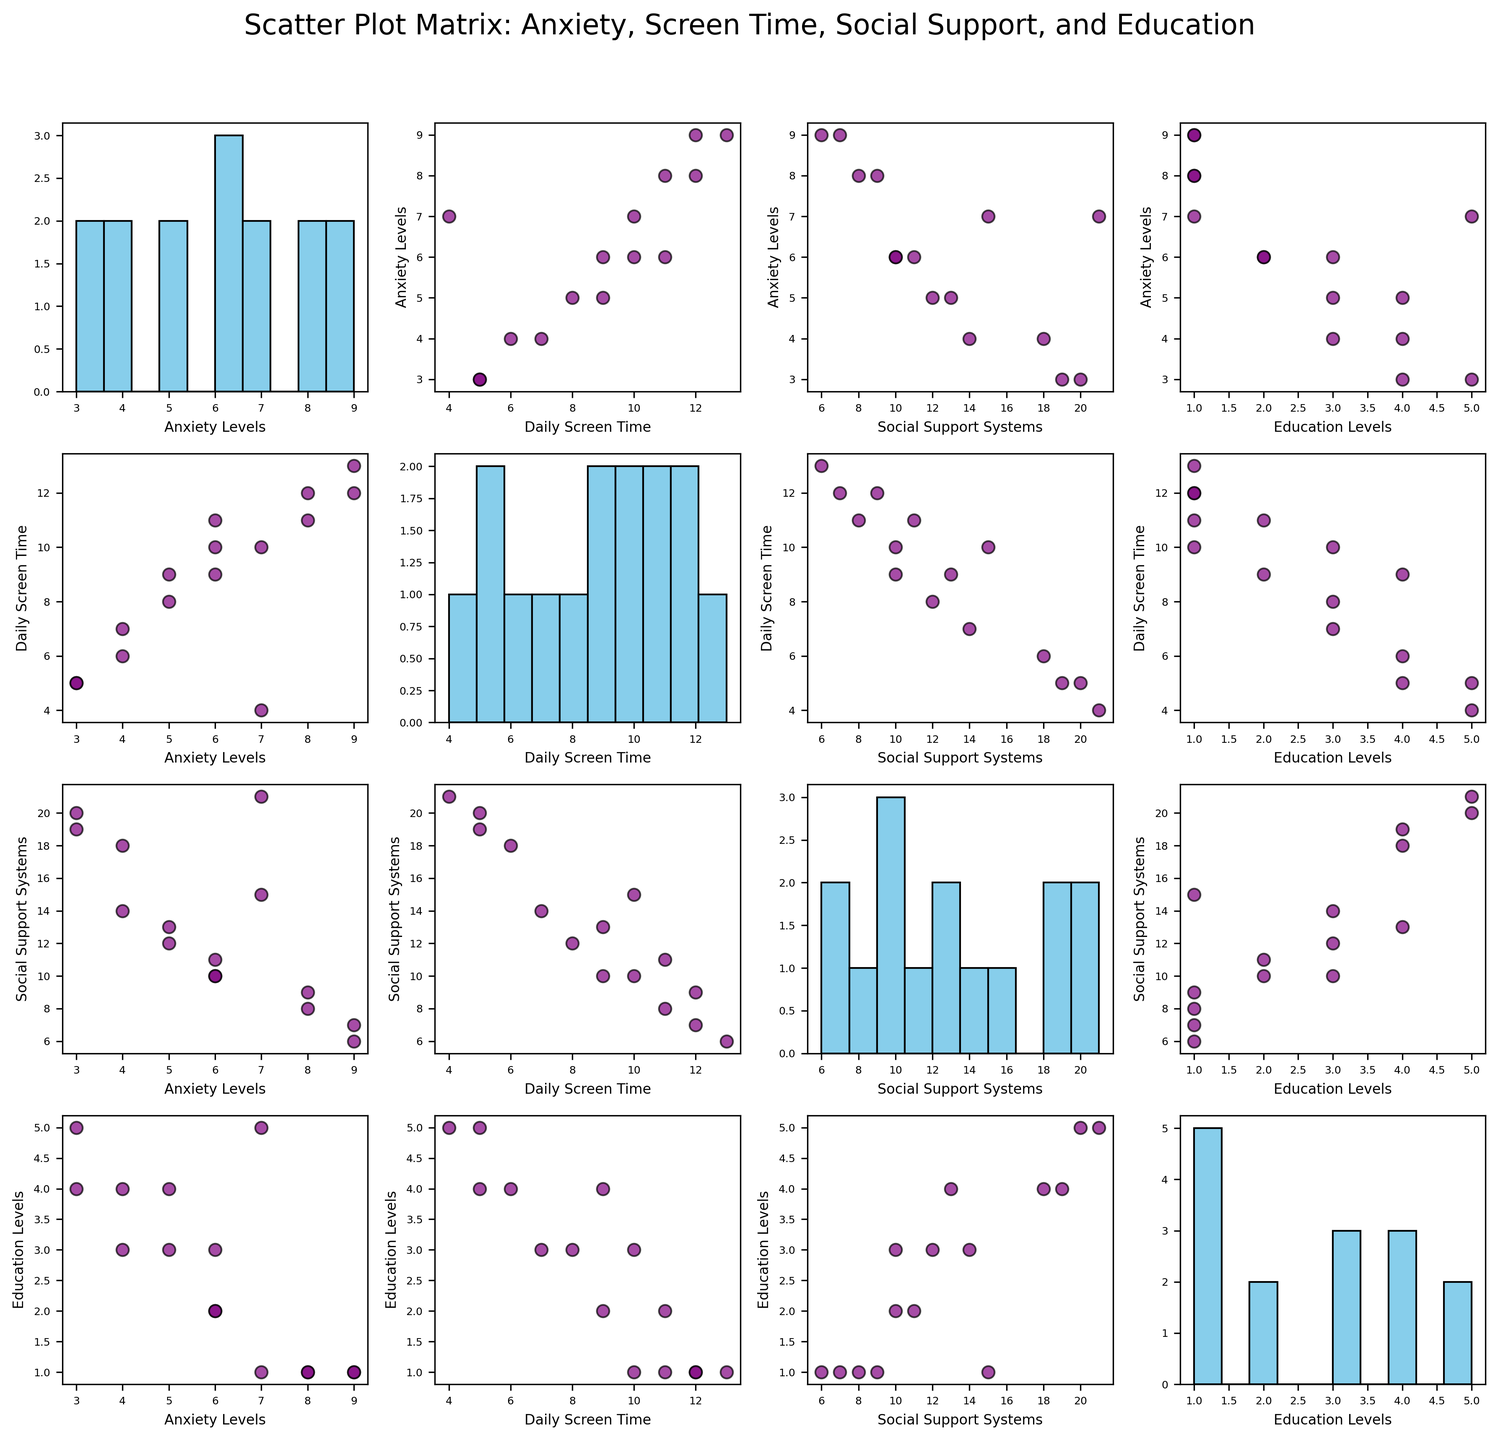What is the title of the figure? The title is typically found at the top of the figure, providing a summary of the data being presented. In this case, it says "Scatter Plot Matrix: Anxiety, Screen Time, Social Support, and Education".
Answer: Scatter Plot Matrix: Anxiety, Screen Time, Social Support, and Education How many variables are plotted in the scatter plot matrix? By counting the rows and columns in the matrix, we see that each row and column corresponds to a different variable. There are four different variables being analyzed.
Answer: Four Which variable seems to have the highest variability based on the histograms on the diagonal? By examining the spread and range of values in each histogram, the variable "Daily Screen Time" appears to have the highest variability as it spans a wide range of values from low to high.
Answer: Daily Screen Time Is there a positive correlation between Anxiety Levels and Daily Screen Time? To determine if there is a positive correlation, we look at the scatter plot intersection between Anxiety Levels and Daily Screen Time. The data points trend upward from left to right, indicating a positive correlation.
Answer: Yes Which education level has the highest representation in the data set? This can be inferred by comparing the frequency of each education level in the corresponding histograms. We see that "High School" has the highest number of data points.
Answer: High School What is the relationship between Social Support Systems and Education Levels? Analyzing the scatter plot between Social Support Systems and Education Levels, we see a downward trend suggesting that higher Education Levels tend to be associated with lower Social Support Systems scores.
Answer: Negative correlation Does higher Social Support Systems correlate with lower Anxiety Levels? Looking at the scatter plot of Anxiety Levels vs. Social Support Systems, we can see a downward trend of the points which suggests an inverse relationship.
Answer: Yes What pattern do you observe between Social Support Systems and Daily Screen Time? Observing the scatter plot between Social Support Systems and Daily Screen Time, the data points show a downward trend, indicating that higher Daily Screen Time might be associated with lower Social Support Systems.
Answer: Negative correlation Are Education Levels and Daily Screen Time correlated? The scatter plot of Education Levels vs. Daily Screen Time shows a relatively scattered distribution without a clear upward or downward trend, suggesting no strong correlation.
Answer: No Which scatter plot shows individual data points with the color purple and black edges? By observing the plots, we can see that all scatter plots use purple points with black edges to represent individual data points. Therefore, all scatter plots exhibit this color scheme.
Answer: All scatter plots 